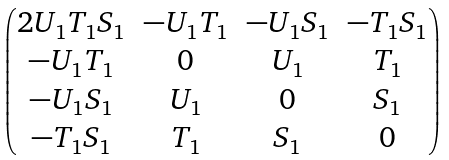Convert formula to latex. <formula><loc_0><loc_0><loc_500><loc_500>\begin{pmatrix} 2 U _ { 1 } T _ { 1 } S _ { 1 } & - U _ { 1 } T _ { 1 } & - U _ { 1 } S _ { 1 } & - T _ { 1 } S _ { 1 } \\ - U _ { 1 } T _ { 1 } & 0 & U _ { 1 } & T _ { 1 } \\ - U _ { 1 } S _ { 1 } & U _ { 1 } & 0 & S _ { 1 } \\ - T _ { 1 } S _ { 1 } & T _ { 1 } & S _ { 1 } & 0 \end{pmatrix}</formula> 